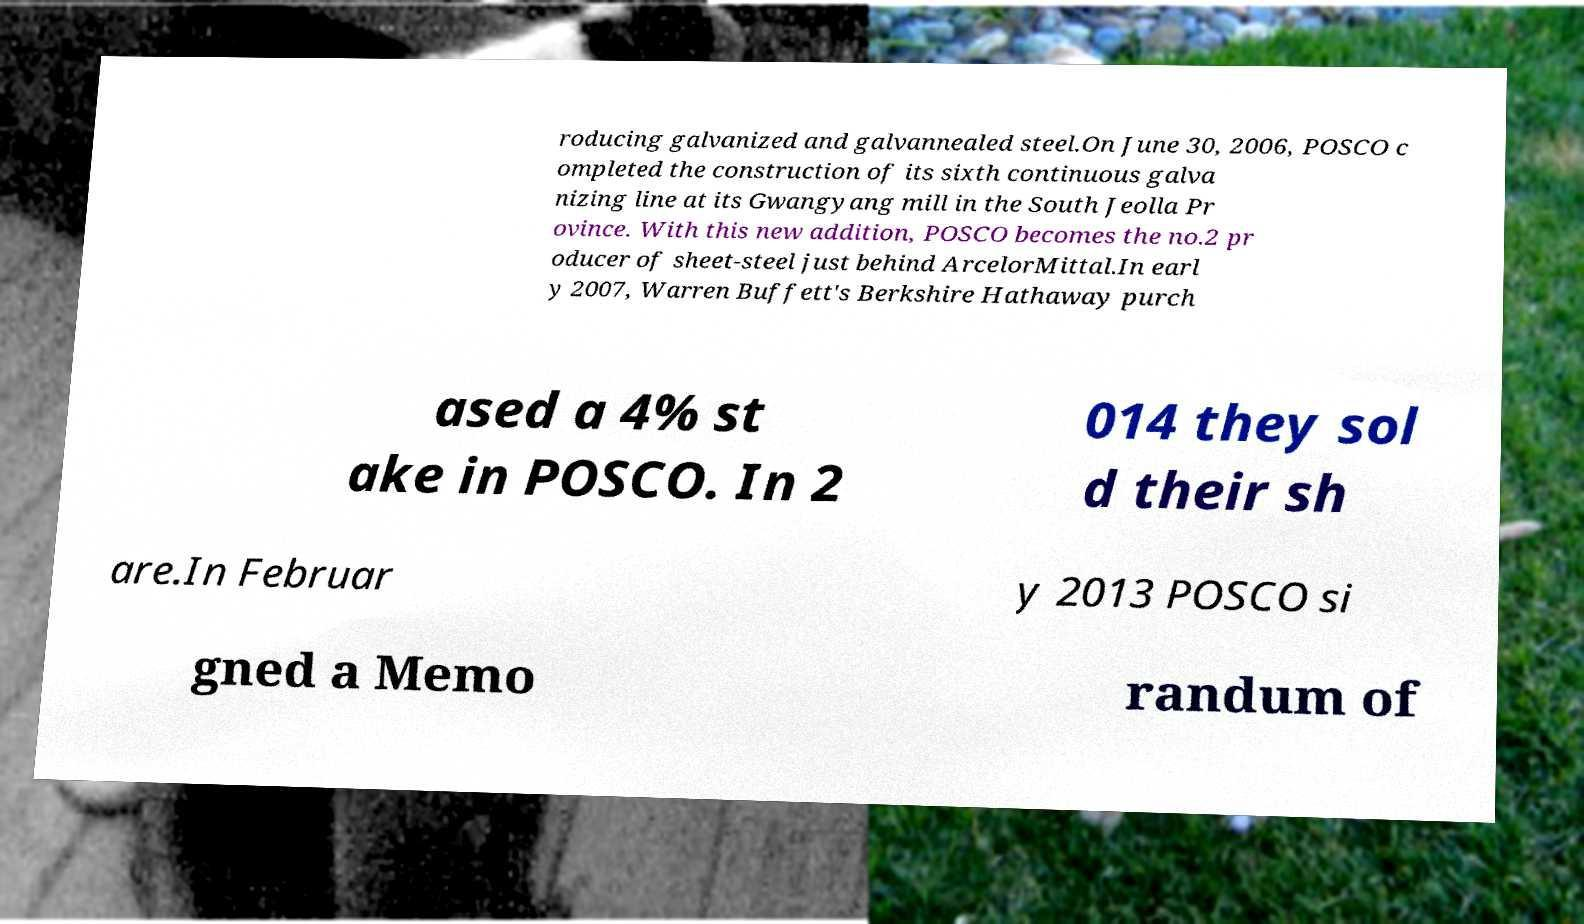Could you assist in decoding the text presented in this image and type it out clearly? roducing galvanized and galvannealed steel.On June 30, 2006, POSCO c ompleted the construction of its sixth continuous galva nizing line at its Gwangyang mill in the South Jeolla Pr ovince. With this new addition, POSCO becomes the no.2 pr oducer of sheet-steel just behind ArcelorMittal.In earl y 2007, Warren Buffett's Berkshire Hathaway purch ased a 4% st ake in POSCO. In 2 014 they sol d their sh are.In Februar y 2013 POSCO si gned a Memo randum of 